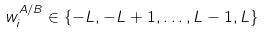Convert formula to latex. <formula><loc_0><loc_0><loc_500><loc_500>w _ { i } ^ { A / B } \in \{ - L , - L + 1 , \dots , L - 1 , L \}</formula> 